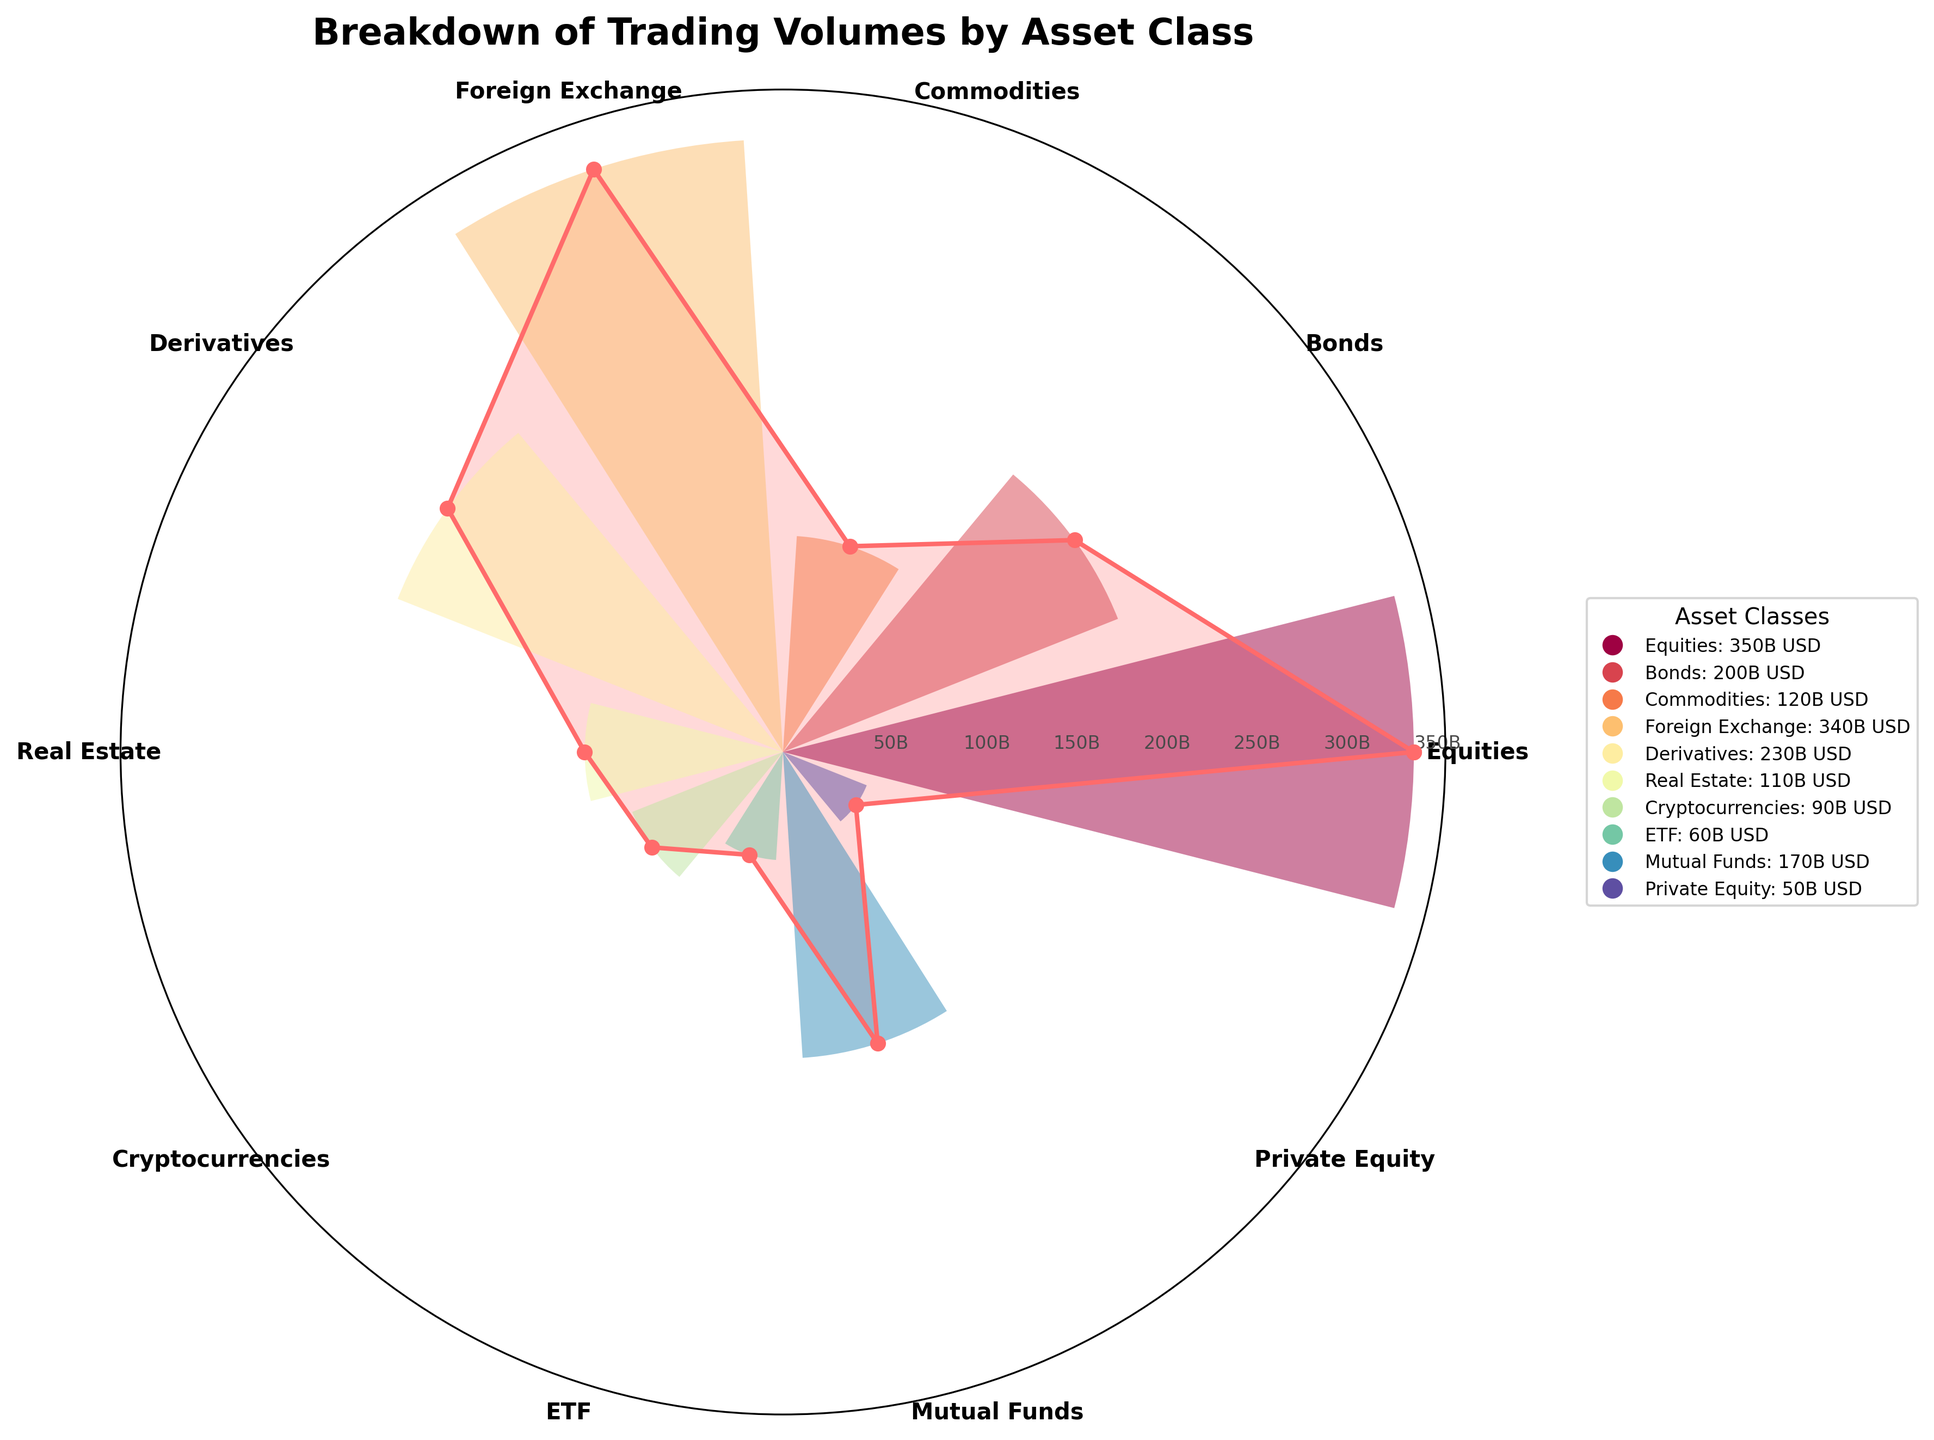What is the title of the chart? The title is displayed prominently at the top of the chart in bold text. It reads "Breakdown of Trading Volumes by Asset Class."
Answer: Breakdown of Trading Volumes by Asset Class How many asset classes are represented in this rose chart? The asset classes are labeled around the circumference of the rose chart. By counting them, we can see that there are 10 asset classes.
Answer: 10 Which asset class has the highest trading volume? Observing the spokes of the chart, the category with the longest bar and filled area represents the highest trading volume. Comparing all categories, Equities has the highest trading volume at 350 billion USD.
Answer: Equities What is the trading volume for Foreign Exchange? Looking at the bar and the labeled angle for Foreign Exchange, it reaches up to the 340 billion USD mark on the radial axis.
Answer: 340 billion USD Which asset class has the smallest trading volume? By comparing the lengths of all the bars from the center, Private Equity has the shortest bar, indicating it has the smallest trading volume at 50 billion USD.
Answer: Private Equity What is the total trading volume of Commodities and Real Estate combined? The trading volumes for Commodities and Real Estate are 120 billion USD and 110 billion USD, respectively. Adding them together gives us 120 + 110 = 230 billion USD.
Answer: 230 billion USD How does the trading volume of Derivatives compare to that of Bonds? The chart shows Derivatives at 230 billion USD and Bonds at 200 billion USD. Derivatives have a higher trading volume than Bonds by 30 billion USD.
Answer: 30 billion USD higher What is the average trading volume across all asset classes? To find the average: (350 + 200 + 120 + 340 + 230 + 110 + 90 + 60 + 170 + 50) / 10 = 1720 / 10 = 172 billion USD.
Answer: 172 billion USD Which asset classes have trading volumes greater than 300 billion USD? The bars for Equities (350 billion USD) and Foreign Exchange (340 billion USD) extend beyond the 300 billion USD mark on the radial axes.
Answer: Equities and Foreign Exchange How much more is the trading volume of Equities compared to Cryptocurrencies? Equities have a trading volume of 350 billion USD and Cryptocurrencies have 90 billion USD. The difference is 350 - 90 = 260 billion USD.
Answer: 260 billion USD 